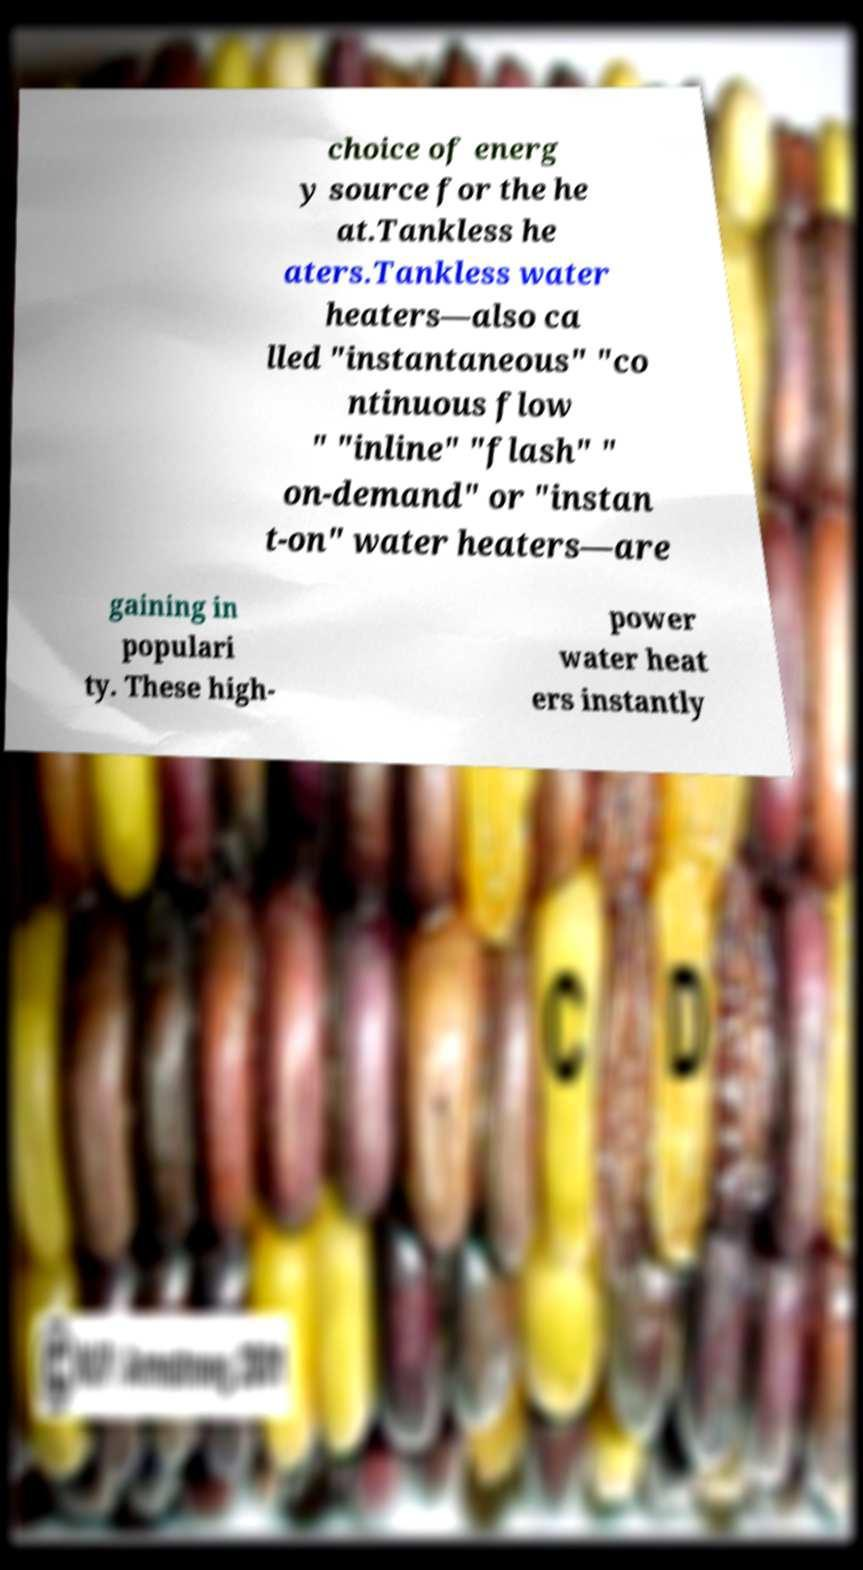There's text embedded in this image that I need extracted. Can you transcribe it verbatim? choice of energ y source for the he at.Tankless he aters.Tankless water heaters—also ca lled "instantaneous" "co ntinuous flow " "inline" "flash" " on-demand" or "instan t-on" water heaters—are gaining in populari ty. These high- power water heat ers instantly 